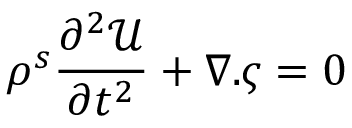Convert formula to latex. <formula><loc_0><loc_0><loc_500><loc_500>\rho ^ { s } \frac { \partial ^ { 2 } \mathcal { U } } { \partial t ^ { 2 } } + \nabla . { \varsigma } = 0</formula> 